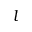Convert formula to latex. <formula><loc_0><loc_0><loc_500><loc_500>l</formula> 